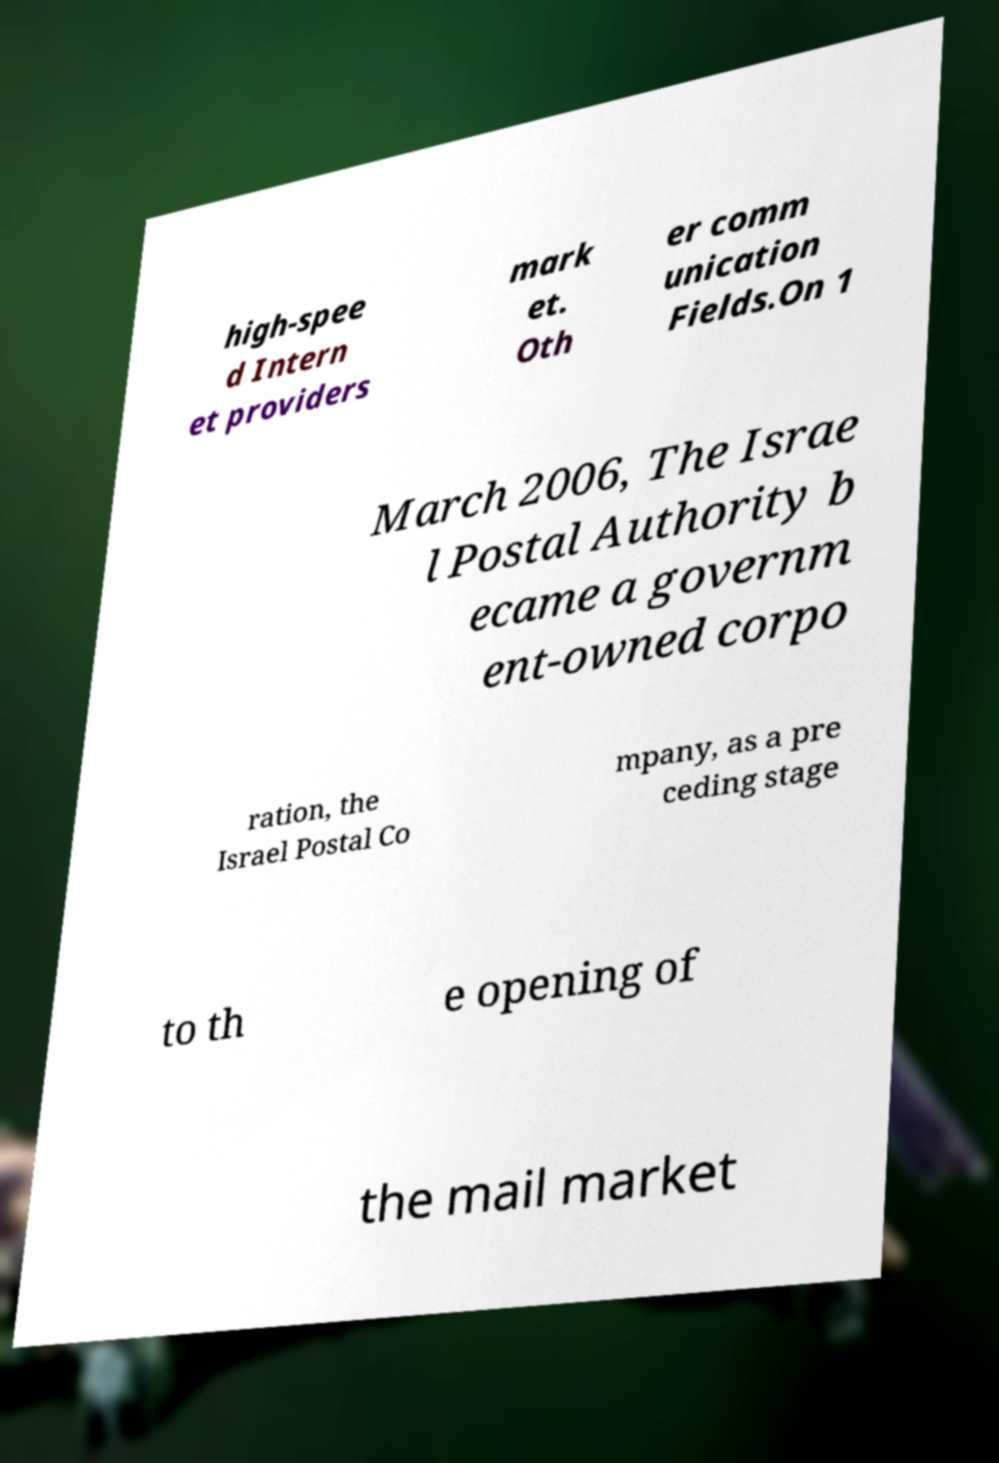There's text embedded in this image that I need extracted. Can you transcribe it verbatim? high-spee d Intern et providers mark et. Oth er comm unication Fields.On 1 March 2006, The Israe l Postal Authority b ecame a governm ent-owned corpo ration, the Israel Postal Co mpany, as a pre ceding stage to th e opening of the mail market 